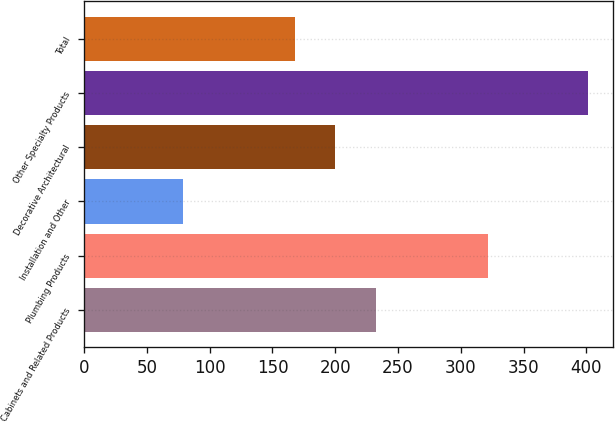Convert chart to OTSL. <chart><loc_0><loc_0><loc_500><loc_500><bar_chart><fcel>Cabinets and Related Products<fcel>Plumbing Products<fcel>Installation and Other<fcel>Decorative Architectural<fcel>Other Specialty Products<fcel>Total<nl><fcel>232.4<fcel>322<fcel>79<fcel>200.2<fcel>401<fcel>168<nl></chart> 